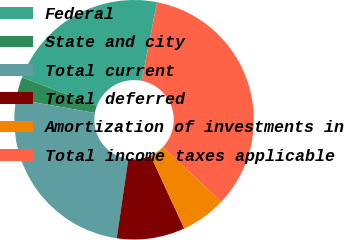Convert chart. <chart><loc_0><loc_0><loc_500><loc_500><pie_chart><fcel>Federal<fcel>State and city<fcel>Total current<fcel>Total deferred<fcel>Amortization of investments in<fcel>Total income taxes applicable<nl><fcel>22.34%<fcel>2.99%<fcel>25.44%<fcel>9.19%<fcel>6.09%<fcel>33.95%<nl></chart> 